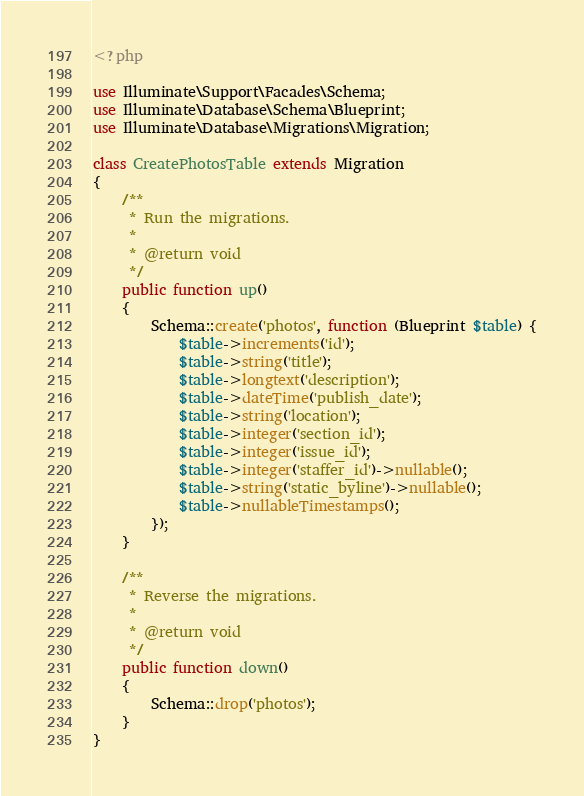Convert code to text. <code><loc_0><loc_0><loc_500><loc_500><_PHP_><?php

use Illuminate\Support\Facades\Schema;
use Illuminate\Database\Schema\Blueprint;
use Illuminate\Database\Migrations\Migration;

class CreatePhotosTable extends Migration
{
    /**
     * Run the migrations.
     *
     * @return void
     */
    public function up()
    {
        Schema::create('photos', function (Blueprint $table) {
            $table->increments('id');
            $table->string('title');
            $table->longtext('description');
            $table->dateTime('publish_date');
            $table->string('location');
            $table->integer('section_id');
            $table->integer('issue_id');
            $table->integer('staffer_id')->nullable();
            $table->string('static_byline')->nullable();
            $table->nullableTimestamps();
        });
    }

    /**
     * Reverse the migrations.
     *
     * @return void
     */
    public function down()
    {
        Schema::drop('photos');
    }
}
</code> 